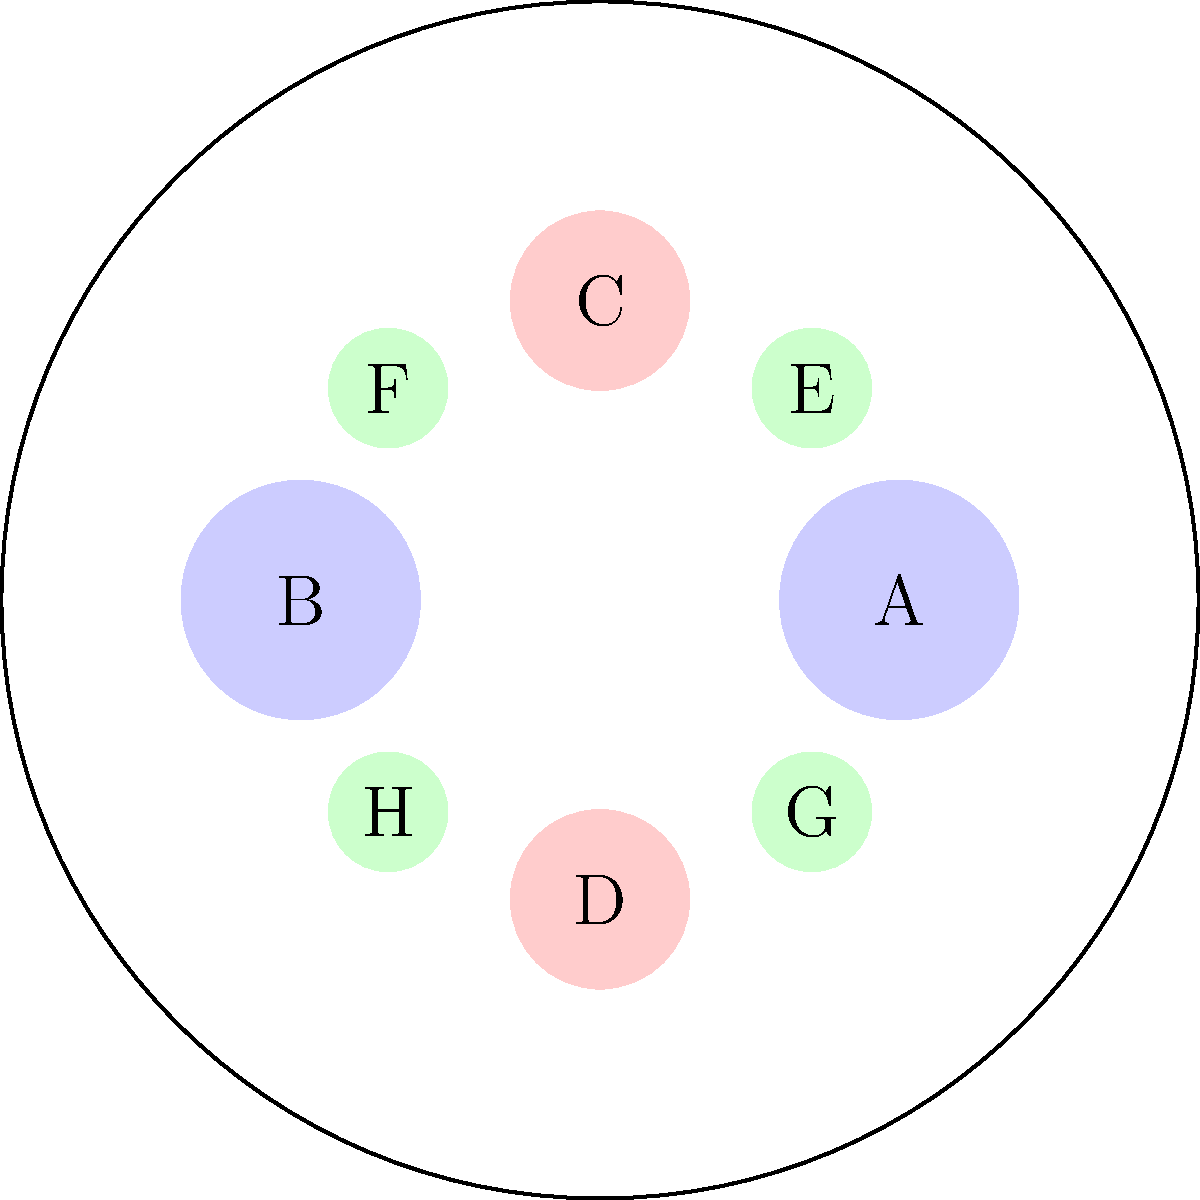You have designed a circular display tray for perfume bottles of various sizes. The arrangement shown maximizes the number of bottles that can fit on the tray. If you were to remove bottles C and D, what is the maximum number of additional small bottles (size E-H) that could be placed in the freed-up space while maintaining the symmetry of the arrangement? To solve this problem, let's follow these steps:

1. Observe the current arrangement:
   - 2 large bottles (A and B)
   - 2 medium bottles (C and D)
   - 4 small bottles (E, F, G, and H)

2. Identify the space freed by removing C and D:
   - These are medium-sized bottles located at the top and bottom of the circular tray.

3. Consider the size difference:
   - The space occupied by one medium bottle can fit more than one small bottle.

4. Maintain symmetry:
   - Any additions must be placed symmetrically to preserve the overall balance of the display.

5. Calculate the maximum number of small bottles:
   - Each medium bottle space can fit 3 small bottles in a triangular arrangement.
   - We have 2 medium bottle spaces available (top and bottom).
   - Therefore, we can fit $2 \times 3 = 6$ small bottles in total.

6. Check symmetry:
   - Adding 3 small bottles to both the top and bottom maintains the symmetrical arrangement.

Thus, 6 additional small bottles can be added while maintaining symmetry.
Answer: 6 bottles 